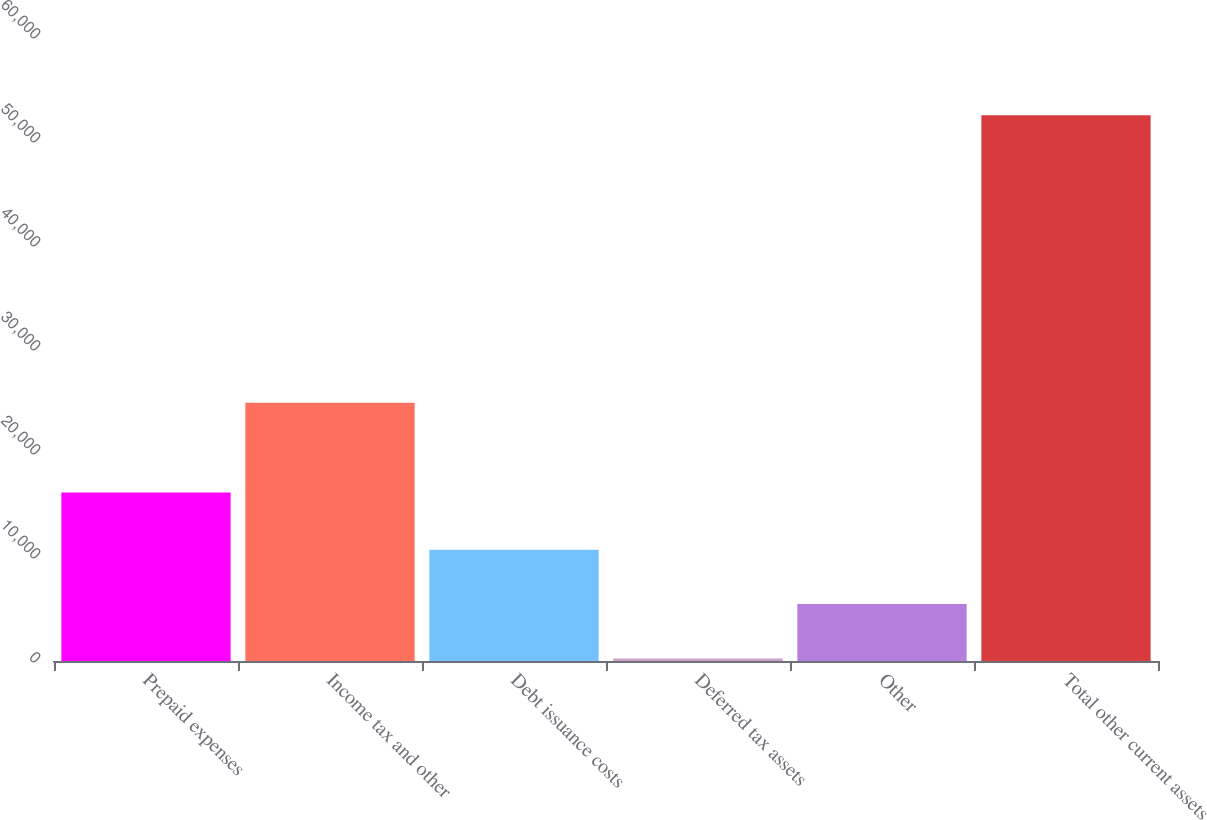<chart> <loc_0><loc_0><loc_500><loc_500><bar_chart><fcel>Prepaid expenses<fcel>Income tax and other<fcel>Debt issuance costs<fcel>Deferred tax assets<fcel>Other<fcel>Total other current assets<nl><fcel>16190<fcel>24821<fcel>10692.6<fcel>247<fcel>5469.8<fcel>52475<nl></chart> 